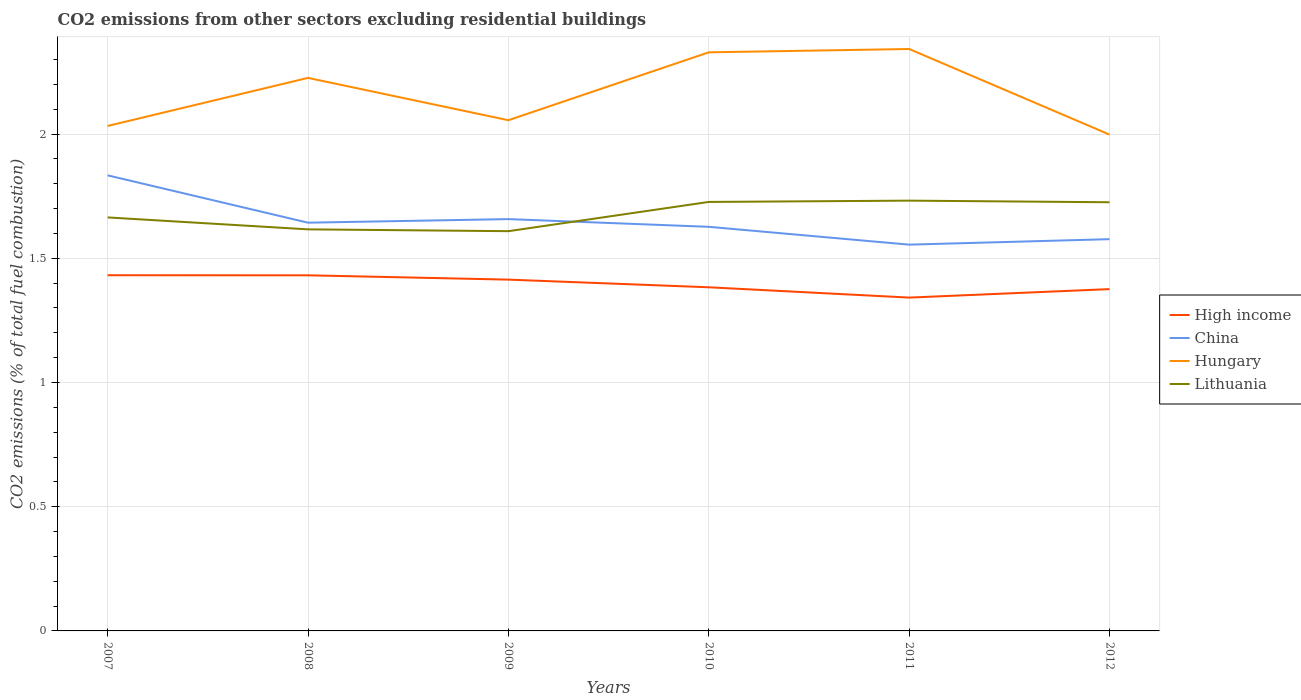How many different coloured lines are there?
Your response must be concise. 4. Across all years, what is the maximum total CO2 emitted in High income?
Provide a short and direct response. 1.34. What is the total total CO2 emitted in Hungary in the graph?
Your answer should be very brief. -0.29. What is the difference between the highest and the second highest total CO2 emitted in High income?
Offer a terse response. 0.09. How many lines are there?
Ensure brevity in your answer.  4. Does the graph contain grids?
Provide a short and direct response. Yes. How are the legend labels stacked?
Offer a terse response. Vertical. What is the title of the graph?
Give a very brief answer. CO2 emissions from other sectors excluding residential buildings. Does "Lesotho" appear as one of the legend labels in the graph?
Your answer should be compact. No. What is the label or title of the X-axis?
Your answer should be compact. Years. What is the label or title of the Y-axis?
Your response must be concise. CO2 emissions (% of total fuel combustion). What is the CO2 emissions (% of total fuel combustion) in High income in 2007?
Your response must be concise. 1.43. What is the CO2 emissions (% of total fuel combustion) of China in 2007?
Offer a very short reply. 1.83. What is the CO2 emissions (% of total fuel combustion) of Hungary in 2007?
Offer a terse response. 2.03. What is the CO2 emissions (% of total fuel combustion) in Lithuania in 2007?
Provide a short and direct response. 1.66. What is the CO2 emissions (% of total fuel combustion) in High income in 2008?
Your response must be concise. 1.43. What is the CO2 emissions (% of total fuel combustion) in China in 2008?
Provide a succinct answer. 1.64. What is the CO2 emissions (% of total fuel combustion) in Hungary in 2008?
Offer a terse response. 2.23. What is the CO2 emissions (% of total fuel combustion) of Lithuania in 2008?
Keep it short and to the point. 1.62. What is the CO2 emissions (% of total fuel combustion) in High income in 2009?
Ensure brevity in your answer.  1.41. What is the CO2 emissions (% of total fuel combustion) in China in 2009?
Your response must be concise. 1.66. What is the CO2 emissions (% of total fuel combustion) in Hungary in 2009?
Offer a very short reply. 2.06. What is the CO2 emissions (% of total fuel combustion) in Lithuania in 2009?
Make the answer very short. 1.61. What is the CO2 emissions (% of total fuel combustion) in High income in 2010?
Make the answer very short. 1.38. What is the CO2 emissions (% of total fuel combustion) in China in 2010?
Provide a short and direct response. 1.63. What is the CO2 emissions (% of total fuel combustion) in Hungary in 2010?
Provide a succinct answer. 2.33. What is the CO2 emissions (% of total fuel combustion) in Lithuania in 2010?
Give a very brief answer. 1.73. What is the CO2 emissions (% of total fuel combustion) in High income in 2011?
Your response must be concise. 1.34. What is the CO2 emissions (% of total fuel combustion) in China in 2011?
Provide a succinct answer. 1.55. What is the CO2 emissions (% of total fuel combustion) in Hungary in 2011?
Ensure brevity in your answer.  2.34. What is the CO2 emissions (% of total fuel combustion) in Lithuania in 2011?
Offer a very short reply. 1.73. What is the CO2 emissions (% of total fuel combustion) in High income in 2012?
Provide a short and direct response. 1.38. What is the CO2 emissions (% of total fuel combustion) of China in 2012?
Make the answer very short. 1.58. What is the CO2 emissions (% of total fuel combustion) in Hungary in 2012?
Keep it short and to the point. 2. What is the CO2 emissions (% of total fuel combustion) of Lithuania in 2012?
Your response must be concise. 1.73. Across all years, what is the maximum CO2 emissions (% of total fuel combustion) of High income?
Ensure brevity in your answer.  1.43. Across all years, what is the maximum CO2 emissions (% of total fuel combustion) in China?
Keep it short and to the point. 1.83. Across all years, what is the maximum CO2 emissions (% of total fuel combustion) in Hungary?
Provide a succinct answer. 2.34. Across all years, what is the maximum CO2 emissions (% of total fuel combustion) in Lithuania?
Keep it short and to the point. 1.73. Across all years, what is the minimum CO2 emissions (% of total fuel combustion) in High income?
Offer a very short reply. 1.34. Across all years, what is the minimum CO2 emissions (% of total fuel combustion) in China?
Offer a terse response. 1.55. Across all years, what is the minimum CO2 emissions (% of total fuel combustion) in Hungary?
Your answer should be compact. 2. Across all years, what is the minimum CO2 emissions (% of total fuel combustion) in Lithuania?
Provide a short and direct response. 1.61. What is the total CO2 emissions (% of total fuel combustion) of High income in the graph?
Your answer should be compact. 8.38. What is the total CO2 emissions (% of total fuel combustion) of China in the graph?
Provide a succinct answer. 9.89. What is the total CO2 emissions (% of total fuel combustion) of Hungary in the graph?
Your response must be concise. 12.98. What is the total CO2 emissions (% of total fuel combustion) in Lithuania in the graph?
Give a very brief answer. 10.07. What is the difference between the CO2 emissions (% of total fuel combustion) of China in 2007 and that in 2008?
Offer a very short reply. 0.19. What is the difference between the CO2 emissions (% of total fuel combustion) in Hungary in 2007 and that in 2008?
Keep it short and to the point. -0.19. What is the difference between the CO2 emissions (% of total fuel combustion) in Lithuania in 2007 and that in 2008?
Your answer should be compact. 0.05. What is the difference between the CO2 emissions (% of total fuel combustion) of High income in 2007 and that in 2009?
Provide a succinct answer. 0.02. What is the difference between the CO2 emissions (% of total fuel combustion) in China in 2007 and that in 2009?
Keep it short and to the point. 0.18. What is the difference between the CO2 emissions (% of total fuel combustion) in Hungary in 2007 and that in 2009?
Your response must be concise. -0.02. What is the difference between the CO2 emissions (% of total fuel combustion) of Lithuania in 2007 and that in 2009?
Your response must be concise. 0.06. What is the difference between the CO2 emissions (% of total fuel combustion) in High income in 2007 and that in 2010?
Your answer should be very brief. 0.05. What is the difference between the CO2 emissions (% of total fuel combustion) of China in 2007 and that in 2010?
Provide a short and direct response. 0.21. What is the difference between the CO2 emissions (% of total fuel combustion) of Hungary in 2007 and that in 2010?
Your response must be concise. -0.3. What is the difference between the CO2 emissions (% of total fuel combustion) of Lithuania in 2007 and that in 2010?
Provide a short and direct response. -0.06. What is the difference between the CO2 emissions (% of total fuel combustion) in High income in 2007 and that in 2011?
Give a very brief answer. 0.09. What is the difference between the CO2 emissions (% of total fuel combustion) in China in 2007 and that in 2011?
Offer a very short reply. 0.28. What is the difference between the CO2 emissions (% of total fuel combustion) of Hungary in 2007 and that in 2011?
Offer a terse response. -0.31. What is the difference between the CO2 emissions (% of total fuel combustion) of Lithuania in 2007 and that in 2011?
Ensure brevity in your answer.  -0.07. What is the difference between the CO2 emissions (% of total fuel combustion) in High income in 2007 and that in 2012?
Offer a very short reply. 0.06. What is the difference between the CO2 emissions (% of total fuel combustion) in China in 2007 and that in 2012?
Offer a very short reply. 0.26. What is the difference between the CO2 emissions (% of total fuel combustion) of Hungary in 2007 and that in 2012?
Your answer should be very brief. 0.03. What is the difference between the CO2 emissions (% of total fuel combustion) of Lithuania in 2007 and that in 2012?
Your answer should be very brief. -0.06. What is the difference between the CO2 emissions (% of total fuel combustion) of High income in 2008 and that in 2009?
Provide a succinct answer. 0.02. What is the difference between the CO2 emissions (% of total fuel combustion) in China in 2008 and that in 2009?
Your response must be concise. -0.01. What is the difference between the CO2 emissions (% of total fuel combustion) of Hungary in 2008 and that in 2009?
Provide a succinct answer. 0.17. What is the difference between the CO2 emissions (% of total fuel combustion) of Lithuania in 2008 and that in 2009?
Your response must be concise. 0.01. What is the difference between the CO2 emissions (% of total fuel combustion) in High income in 2008 and that in 2010?
Make the answer very short. 0.05. What is the difference between the CO2 emissions (% of total fuel combustion) in China in 2008 and that in 2010?
Your answer should be very brief. 0.02. What is the difference between the CO2 emissions (% of total fuel combustion) of Hungary in 2008 and that in 2010?
Make the answer very short. -0.1. What is the difference between the CO2 emissions (% of total fuel combustion) of Lithuania in 2008 and that in 2010?
Your answer should be very brief. -0.11. What is the difference between the CO2 emissions (% of total fuel combustion) of High income in 2008 and that in 2011?
Give a very brief answer. 0.09. What is the difference between the CO2 emissions (% of total fuel combustion) in China in 2008 and that in 2011?
Ensure brevity in your answer.  0.09. What is the difference between the CO2 emissions (% of total fuel combustion) in Hungary in 2008 and that in 2011?
Offer a terse response. -0.12. What is the difference between the CO2 emissions (% of total fuel combustion) in Lithuania in 2008 and that in 2011?
Your answer should be very brief. -0.12. What is the difference between the CO2 emissions (% of total fuel combustion) in High income in 2008 and that in 2012?
Your answer should be compact. 0.06. What is the difference between the CO2 emissions (% of total fuel combustion) of China in 2008 and that in 2012?
Ensure brevity in your answer.  0.07. What is the difference between the CO2 emissions (% of total fuel combustion) of Hungary in 2008 and that in 2012?
Give a very brief answer. 0.23. What is the difference between the CO2 emissions (% of total fuel combustion) in Lithuania in 2008 and that in 2012?
Provide a short and direct response. -0.11. What is the difference between the CO2 emissions (% of total fuel combustion) of High income in 2009 and that in 2010?
Your answer should be very brief. 0.03. What is the difference between the CO2 emissions (% of total fuel combustion) in China in 2009 and that in 2010?
Your answer should be very brief. 0.03. What is the difference between the CO2 emissions (% of total fuel combustion) of Hungary in 2009 and that in 2010?
Your response must be concise. -0.27. What is the difference between the CO2 emissions (% of total fuel combustion) in Lithuania in 2009 and that in 2010?
Your answer should be compact. -0.12. What is the difference between the CO2 emissions (% of total fuel combustion) in High income in 2009 and that in 2011?
Provide a short and direct response. 0.07. What is the difference between the CO2 emissions (% of total fuel combustion) in China in 2009 and that in 2011?
Your answer should be compact. 0.1. What is the difference between the CO2 emissions (% of total fuel combustion) in Hungary in 2009 and that in 2011?
Make the answer very short. -0.29. What is the difference between the CO2 emissions (% of total fuel combustion) in Lithuania in 2009 and that in 2011?
Make the answer very short. -0.12. What is the difference between the CO2 emissions (% of total fuel combustion) of High income in 2009 and that in 2012?
Your answer should be very brief. 0.04. What is the difference between the CO2 emissions (% of total fuel combustion) in China in 2009 and that in 2012?
Your answer should be compact. 0.08. What is the difference between the CO2 emissions (% of total fuel combustion) in Hungary in 2009 and that in 2012?
Provide a short and direct response. 0.06. What is the difference between the CO2 emissions (% of total fuel combustion) in Lithuania in 2009 and that in 2012?
Offer a terse response. -0.12. What is the difference between the CO2 emissions (% of total fuel combustion) in High income in 2010 and that in 2011?
Offer a very short reply. 0.04. What is the difference between the CO2 emissions (% of total fuel combustion) in China in 2010 and that in 2011?
Ensure brevity in your answer.  0.07. What is the difference between the CO2 emissions (% of total fuel combustion) of Hungary in 2010 and that in 2011?
Give a very brief answer. -0.01. What is the difference between the CO2 emissions (% of total fuel combustion) in Lithuania in 2010 and that in 2011?
Ensure brevity in your answer.  -0.01. What is the difference between the CO2 emissions (% of total fuel combustion) in High income in 2010 and that in 2012?
Your answer should be compact. 0.01. What is the difference between the CO2 emissions (% of total fuel combustion) of China in 2010 and that in 2012?
Your answer should be very brief. 0.05. What is the difference between the CO2 emissions (% of total fuel combustion) of Hungary in 2010 and that in 2012?
Your response must be concise. 0.33. What is the difference between the CO2 emissions (% of total fuel combustion) in Lithuania in 2010 and that in 2012?
Ensure brevity in your answer.  0. What is the difference between the CO2 emissions (% of total fuel combustion) of High income in 2011 and that in 2012?
Ensure brevity in your answer.  -0.03. What is the difference between the CO2 emissions (% of total fuel combustion) in China in 2011 and that in 2012?
Keep it short and to the point. -0.02. What is the difference between the CO2 emissions (% of total fuel combustion) of Hungary in 2011 and that in 2012?
Keep it short and to the point. 0.34. What is the difference between the CO2 emissions (% of total fuel combustion) of Lithuania in 2011 and that in 2012?
Make the answer very short. 0.01. What is the difference between the CO2 emissions (% of total fuel combustion) of High income in 2007 and the CO2 emissions (% of total fuel combustion) of China in 2008?
Your answer should be very brief. -0.21. What is the difference between the CO2 emissions (% of total fuel combustion) of High income in 2007 and the CO2 emissions (% of total fuel combustion) of Hungary in 2008?
Keep it short and to the point. -0.79. What is the difference between the CO2 emissions (% of total fuel combustion) of High income in 2007 and the CO2 emissions (% of total fuel combustion) of Lithuania in 2008?
Provide a short and direct response. -0.18. What is the difference between the CO2 emissions (% of total fuel combustion) in China in 2007 and the CO2 emissions (% of total fuel combustion) in Hungary in 2008?
Your response must be concise. -0.39. What is the difference between the CO2 emissions (% of total fuel combustion) in China in 2007 and the CO2 emissions (% of total fuel combustion) in Lithuania in 2008?
Your answer should be compact. 0.22. What is the difference between the CO2 emissions (% of total fuel combustion) of Hungary in 2007 and the CO2 emissions (% of total fuel combustion) of Lithuania in 2008?
Your answer should be compact. 0.42. What is the difference between the CO2 emissions (% of total fuel combustion) of High income in 2007 and the CO2 emissions (% of total fuel combustion) of China in 2009?
Your response must be concise. -0.23. What is the difference between the CO2 emissions (% of total fuel combustion) in High income in 2007 and the CO2 emissions (% of total fuel combustion) in Hungary in 2009?
Your answer should be very brief. -0.62. What is the difference between the CO2 emissions (% of total fuel combustion) in High income in 2007 and the CO2 emissions (% of total fuel combustion) in Lithuania in 2009?
Keep it short and to the point. -0.18. What is the difference between the CO2 emissions (% of total fuel combustion) of China in 2007 and the CO2 emissions (% of total fuel combustion) of Hungary in 2009?
Make the answer very short. -0.22. What is the difference between the CO2 emissions (% of total fuel combustion) in China in 2007 and the CO2 emissions (% of total fuel combustion) in Lithuania in 2009?
Offer a terse response. 0.22. What is the difference between the CO2 emissions (% of total fuel combustion) of Hungary in 2007 and the CO2 emissions (% of total fuel combustion) of Lithuania in 2009?
Offer a terse response. 0.42. What is the difference between the CO2 emissions (% of total fuel combustion) in High income in 2007 and the CO2 emissions (% of total fuel combustion) in China in 2010?
Give a very brief answer. -0.19. What is the difference between the CO2 emissions (% of total fuel combustion) in High income in 2007 and the CO2 emissions (% of total fuel combustion) in Hungary in 2010?
Make the answer very short. -0.9. What is the difference between the CO2 emissions (% of total fuel combustion) of High income in 2007 and the CO2 emissions (% of total fuel combustion) of Lithuania in 2010?
Your response must be concise. -0.3. What is the difference between the CO2 emissions (% of total fuel combustion) in China in 2007 and the CO2 emissions (% of total fuel combustion) in Hungary in 2010?
Ensure brevity in your answer.  -0.5. What is the difference between the CO2 emissions (% of total fuel combustion) in China in 2007 and the CO2 emissions (% of total fuel combustion) in Lithuania in 2010?
Provide a succinct answer. 0.11. What is the difference between the CO2 emissions (% of total fuel combustion) of Hungary in 2007 and the CO2 emissions (% of total fuel combustion) of Lithuania in 2010?
Provide a short and direct response. 0.31. What is the difference between the CO2 emissions (% of total fuel combustion) in High income in 2007 and the CO2 emissions (% of total fuel combustion) in China in 2011?
Your answer should be very brief. -0.12. What is the difference between the CO2 emissions (% of total fuel combustion) in High income in 2007 and the CO2 emissions (% of total fuel combustion) in Hungary in 2011?
Offer a terse response. -0.91. What is the difference between the CO2 emissions (% of total fuel combustion) in High income in 2007 and the CO2 emissions (% of total fuel combustion) in Lithuania in 2011?
Provide a succinct answer. -0.3. What is the difference between the CO2 emissions (% of total fuel combustion) of China in 2007 and the CO2 emissions (% of total fuel combustion) of Hungary in 2011?
Provide a short and direct response. -0.51. What is the difference between the CO2 emissions (% of total fuel combustion) of China in 2007 and the CO2 emissions (% of total fuel combustion) of Lithuania in 2011?
Your answer should be very brief. 0.1. What is the difference between the CO2 emissions (% of total fuel combustion) of Hungary in 2007 and the CO2 emissions (% of total fuel combustion) of Lithuania in 2011?
Offer a very short reply. 0.3. What is the difference between the CO2 emissions (% of total fuel combustion) of High income in 2007 and the CO2 emissions (% of total fuel combustion) of China in 2012?
Give a very brief answer. -0.15. What is the difference between the CO2 emissions (% of total fuel combustion) in High income in 2007 and the CO2 emissions (% of total fuel combustion) in Hungary in 2012?
Provide a short and direct response. -0.57. What is the difference between the CO2 emissions (% of total fuel combustion) of High income in 2007 and the CO2 emissions (% of total fuel combustion) of Lithuania in 2012?
Keep it short and to the point. -0.29. What is the difference between the CO2 emissions (% of total fuel combustion) in China in 2007 and the CO2 emissions (% of total fuel combustion) in Hungary in 2012?
Ensure brevity in your answer.  -0.16. What is the difference between the CO2 emissions (% of total fuel combustion) of China in 2007 and the CO2 emissions (% of total fuel combustion) of Lithuania in 2012?
Keep it short and to the point. 0.11. What is the difference between the CO2 emissions (% of total fuel combustion) of Hungary in 2007 and the CO2 emissions (% of total fuel combustion) of Lithuania in 2012?
Keep it short and to the point. 0.31. What is the difference between the CO2 emissions (% of total fuel combustion) in High income in 2008 and the CO2 emissions (% of total fuel combustion) in China in 2009?
Offer a terse response. -0.23. What is the difference between the CO2 emissions (% of total fuel combustion) in High income in 2008 and the CO2 emissions (% of total fuel combustion) in Hungary in 2009?
Your answer should be compact. -0.62. What is the difference between the CO2 emissions (% of total fuel combustion) in High income in 2008 and the CO2 emissions (% of total fuel combustion) in Lithuania in 2009?
Provide a succinct answer. -0.18. What is the difference between the CO2 emissions (% of total fuel combustion) of China in 2008 and the CO2 emissions (% of total fuel combustion) of Hungary in 2009?
Provide a short and direct response. -0.41. What is the difference between the CO2 emissions (% of total fuel combustion) in China in 2008 and the CO2 emissions (% of total fuel combustion) in Lithuania in 2009?
Your answer should be very brief. 0.03. What is the difference between the CO2 emissions (% of total fuel combustion) of Hungary in 2008 and the CO2 emissions (% of total fuel combustion) of Lithuania in 2009?
Ensure brevity in your answer.  0.62. What is the difference between the CO2 emissions (% of total fuel combustion) in High income in 2008 and the CO2 emissions (% of total fuel combustion) in China in 2010?
Your answer should be compact. -0.2. What is the difference between the CO2 emissions (% of total fuel combustion) in High income in 2008 and the CO2 emissions (% of total fuel combustion) in Hungary in 2010?
Make the answer very short. -0.9. What is the difference between the CO2 emissions (% of total fuel combustion) of High income in 2008 and the CO2 emissions (% of total fuel combustion) of Lithuania in 2010?
Give a very brief answer. -0.3. What is the difference between the CO2 emissions (% of total fuel combustion) of China in 2008 and the CO2 emissions (% of total fuel combustion) of Hungary in 2010?
Your answer should be very brief. -0.69. What is the difference between the CO2 emissions (% of total fuel combustion) of China in 2008 and the CO2 emissions (% of total fuel combustion) of Lithuania in 2010?
Your answer should be compact. -0.08. What is the difference between the CO2 emissions (% of total fuel combustion) in Hungary in 2008 and the CO2 emissions (% of total fuel combustion) in Lithuania in 2010?
Make the answer very short. 0.5. What is the difference between the CO2 emissions (% of total fuel combustion) of High income in 2008 and the CO2 emissions (% of total fuel combustion) of China in 2011?
Ensure brevity in your answer.  -0.12. What is the difference between the CO2 emissions (% of total fuel combustion) of High income in 2008 and the CO2 emissions (% of total fuel combustion) of Hungary in 2011?
Make the answer very short. -0.91. What is the difference between the CO2 emissions (% of total fuel combustion) in High income in 2008 and the CO2 emissions (% of total fuel combustion) in Lithuania in 2011?
Give a very brief answer. -0.3. What is the difference between the CO2 emissions (% of total fuel combustion) of China in 2008 and the CO2 emissions (% of total fuel combustion) of Hungary in 2011?
Your response must be concise. -0.7. What is the difference between the CO2 emissions (% of total fuel combustion) in China in 2008 and the CO2 emissions (% of total fuel combustion) in Lithuania in 2011?
Keep it short and to the point. -0.09. What is the difference between the CO2 emissions (% of total fuel combustion) in Hungary in 2008 and the CO2 emissions (% of total fuel combustion) in Lithuania in 2011?
Keep it short and to the point. 0.49. What is the difference between the CO2 emissions (% of total fuel combustion) of High income in 2008 and the CO2 emissions (% of total fuel combustion) of China in 2012?
Make the answer very short. -0.15. What is the difference between the CO2 emissions (% of total fuel combustion) of High income in 2008 and the CO2 emissions (% of total fuel combustion) of Hungary in 2012?
Offer a terse response. -0.57. What is the difference between the CO2 emissions (% of total fuel combustion) in High income in 2008 and the CO2 emissions (% of total fuel combustion) in Lithuania in 2012?
Provide a succinct answer. -0.29. What is the difference between the CO2 emissions (% of total fuel combustion) of China in 2008 and the CO2 emissions (% of total fuel combustion) of Hungary in 2012?
Your answer should be very brief. -0.35. What is the difference between the CO2 emissions (% of total fuel combustion) in China in 2008 and the CO2 emissions (% of total fuel combustion) in Lithuania in 2012?
Give a very brief answer. -0.08. What is the difference between the CO2 emissions (% of total fuel combustion) in Hungary in 2008 and the CO2 emissions (% of total fuel combustion) in Lithuania in 2012?
Your answer should be compact. 0.5. What is the difference between the CO2 emissions (% of total fuel combustion) of High income in 2009 and the CO2 emissions (% of total fuel combustion) of China in 2010?
Offer a very short reply. -0.21. What is the difference between the CO2 emissions (% of total fuel combustion) of High income in 2009 and the CO2 emissions (% of total fuel combustion) of Hungary in 2010?
Ensure brevity in your answer.  -0.91. What is the difference between the CO2 emissions (% of total fuel combustion) of High income in 2009 and the CO2 emissions (% of total fuel combustion) of Lithuania in 2010?
Keep it short and to the point. -0.31. What is the difference between the CO2 emissions (% of total fuel combustion) in China in 2009 and the CO2 emissions (% of total fuel combustion) in Hungary in 2010?
Give a very brief answer. -0.67. What is the difference between the CO2 emissions (% of total fuel combustion) in China in 2009 and the CO2 emissions (% of total fuel combustion) in Lithuania in 2010?
Keep it short and to the point. -0.07. What is the difference between the CO2 emissions (% of total fuel combustion) in Hungary in 2009 and the CO2 emissions (% of total fuel combustion) in Lithuania in 2010?
Your answer should be very brief. 0.33. What is the difference between the CO2 emissions (% of total fuel combustion) of High income in 2009 and the CO2 emissions (% of total fuel combustion) of China in 2011?
Provide a short and direct response. -0.14. What is the difference between the CO2 emissions (% of total fuel combustion) in High income in 2009 and the CO2 emissions (% of total fuel combustion) in Hungary in 2011?
Your answer should be compact. -0.93. What is the difference between the CO2 emissions (% of total fuel combustion) of High income in 2009 and the CO2 emissions (% of total fuel combustion) of Lithuania in 2011?
Your answer should be compact. -0.32. What is the difference between the CO2 emissions (% of total fuel combustion) of China in 2009 and the CO2 emissions (% of total fuel combustion) of Hungary in 2011?
Offer a very short reply. -0.68. What is the difference between the CO2 emissions (% of total fuel combustion) in China in 2009 and the CO2 emissions (% of total fuel combustion) in Lithuania in 2011?
Give a very brief answer. -0.07. What is the difference between the CO2 emissions (% of total fuel combustion) of Hungary in 2009 and the CO2 emissions (% of total fuel combustion) of Lithuania in 2011?
Give a very brief answer. 0.32. What is the difference between the CO2 emissions (% of total fuel combustion) in High income in 2009 and the CO2 emissions (% of total fuel combustion) in China in 2012?
Keep it short and to the point. -0.16. What is the difference between the CO2 emissions (% of total fuel combustion) of High income in 2009 and the CO2 emissions (% of total fuel combustion) of Hungary in 2012?
Your response must be concise. -0.58. What is the difference between the CO2 emissions (% of total fuel combustion) in High income in 2009 and the CO2 emissions (% of total fuel combustion) in Lithuania in 2012?
Offer a very short reply. -0.31. What is the difference between the CO2 emissions (% of total fuel combustion) in China in 2009 and the CO2 emissions (% of total fuel combustion) in Hungary in 2012?
Make the answer very short. -0.34. What is the difference between the CO2 emissions (% of total fuel combustion) of China in 2009 and the CO2 emissions (% of total fuel combustion) of Lithuania in 2012?
Provide a short and direct response. -0.07. What is the difference between the CO2 emissions (% of total fuel combustion) of Hungary in 2009 and the CO2 emissions (% of total fuel combustion) of Lithuania in 2012?
Ensure brevity in your answer.  0.33. What is the difference between the CO2 emissions (% of total fuel combustion) of High income in 2010 and the CO2 emissions (% of total fuel combustion) of China in 2011?
Offer a terse response. -0.17. What is the difference between the CO2 emissions (% of total fuel combustion) of High income in 2010 and the CO2 emissions (% of total fuel combustion) of Hungary in 2011?
Offer a terse response. -0.96. What is the difference between the CO2 emissions (% of total fuel combustion) of High income in 2010 and the CO2 emissions (% of total fuel combustion) of Lithuania in 2011?
Keep it short and to the point. -0.35. What is the difference between the CO2 emissions (% of total fuel combustion) in China in 2010 and the CO2 emissions (% of total fuel combustion) in Hungary in 2011?
Ensure brevity in your answer.  -0.72. What is the difference between the CO2 emissions (% of total fuel combustion) of China in 2010 and the CO2 emissions (% of total fuel combustion) of Lithuania in 2011?
Offer a terse response. -0.11. What is the difference between the CO2 emissions (% of total fuel combustion) of Hungary in 2010 and the CO2 emissions (% of total fuel combustion) of Lithuania in 2011?
Your response must be concise. 0.6. What is the difference between the CO2 emissions (% of total fuel combustion) in High income in 2010 and the CO2 emissions (% of total fuel combustion) in China in 2012?
Your response must be concise. -0.19. What is the difference between the CO2 emissions (% of total fuel combustion) of High income in 2010 and the CO2 emissions (% of total fuel combustion) of Hungary in 2012?
Your answer should be compact. -0.61. What is the difference between the CO2 emissions (% of total fuel combustion) in High income in 2010 and the CO2 emissions (% of total fuel combustion) in Lithuania in 2012?
Ensure brevity in your answer.  -0.34. What is the difference between the CO2 emissions (% of total fuel combustion) of China in 2010 and the CO2 emissions (% of total fuel combustion) of Hungary in 2012?
Your answer should be compact. -0.37. What is the difference between the CO2 emissions (% of total fuel combustion) of China in 2010 and the CO2 emissions (% of total fuel combustion) of Lithuania in 2012?
Keep it short and to the point. -0.1. What is the difference between the CO2 emissions (% of total fuel combustion) in Hungary in 2010 and the CO2 emissions (% of total fuel combustion) in Lithuania in 2012?
Your response must be concise. 0.6. What is the difference between the CO2 emissions (% of total fuel combustion) of High income in 2011 and the CO2 emissions (% of total fuel combustion) of China in 2012?
Provide a short and direct response. -0.24. What is the difference between the CO2 emissions (% of total fuel combustion) of High income in 2011 and the CO2 emissions (% of total fuel combustion) of Hungary in 2012?
Offer a terse response. -0.66. What is the difference between the CO2 emissions (% of total fuel combustion) of High income in 2011 and the CO2 emissions (% of total fuel combustion) of Lithuania in 2012?
Keep it short and to the point. -0.38. What is the difference between the CO2 emissions (% of total fuel combustion) of China in 2011 and the CO2 emissions (% of total fuel combustion) of Hungary in 2012?
Offer a terse response. -0.44. What is the difference between the CO2 emissions (% of total fuel combustion) of China in 2011 and the CO2 emissions (% of total fuel combustion) of Lithuania in 2012?
Give a very brief answer. -0.17. What is the difference between the CO2 emissions (% of total fuel combustion) of Hungary in 2011 and the CO2 emissions (% of total fuel combustion) of Lithuania in 2012?
Your response must be concise. 0.62. What is the average CO2 emissions (% of total fuel combustion) of High income per year?
Your response must be concise. 1.4. What is the average CO2 emissions (% of total fuel combustion) of China per year?
Your answer should be compact. 1.65. What is the average CO2 emissions (% of total fuel combustion) in Hungary per year?
Offer a very short reply. 2.16. What is the average CO2 emissions (% of total fuel combustion) of Lithuania per year?
Provide a succinct answer. 1.68. In the year 2007, what is the difference between the CO2 emissions (% of total fuel combustion) of High income and CO2 emissions (% of total fuel combustion) of China?
Your response must be concise. -0.4. In the year 2007, what is the difference between the CO2 emissions (% of total fuel combustion) in High income and CO2 emissions (% of total fuel combustion) in Hungary?
Give a very brief answer. -0.6. In the year 2007, what is the difference between the CO2 emissions (% of total fuel combustion) of High income and CO2 emissions (% of total fuel combustion) of Lithuania?
Offer a terse response. -0.23. In the year 2007, what is the difference between the CO2 emissions (% of total fuel combustion) in China and CO2 emissions (% of total fuel combustion) in Hungary?
Ensure brevity in your answer.  -0.2. In the year 2007, what is the difference between the CO2 emissions (% of total fuel combustion) of China and CO2 emissions (% of total fuel combustion) of Lithuania?
Your response must be concise. 0.17. In the year 2007, what is the difference between the CO2 emissions (% of total fuel combustion) of Hungary and CO2 emissions (% of total fuel combustion) of Lithuania?
Offer a very short reply. 0.37. In the year 2008, what is the difference between the CO2 emissions (% of total fuel combustion) in High income and CO2 emissions (% of total fuel combustion) in China?
Offer a very short reply. -0.21. In the year 2008, what is the difference between the CO2 emissions (% of total fuel combustion) in High income and CO2 emissions (% of total fuel combustion) in Hungary?
Ensure brevity in your answer.  -0.79. In the year 2008, what is the difference between the CO2 emissions (% of total fuel combustion) of High income and CO2 emissions (% of total fuel combustion) of Lithuania?
Make the answer very short. -0.18. In the year 2008, what is the difference between the CO2 emissions (% of total fuel combustion) in China and CO2 emissions (% of total fuel combustion) in Hungary?
Give a very brief answer. -0.58. In the year 2008, what is the difference between the CO2 emissions (% of total fuel combustion) in China and CO2 emissions (% of total fuel combustion) in Lithuania?
Provide a short and direct response. 0.03. In the year 2008, what is the difference between the CO2 emissions (% of total fuel combustion) of Hungary and CO2 emissions (% of total fuel combustion) of Lithuania?
Ensure brevity in your answer.  0.61. In the year 2009, what is the difference between the CO2 emissions (% of total fuel combustion) in High income and CO2 emissions (% of total fuel combustion) in China?
Provide a succinct answer. -0.24. In the year 2009, what is the difference between the CO2 emissions (% of total fuel combustion) of High income and CO2 emissions (% of total fuel combustion) of Hungary?
Ensure brevity in your answer.  -0.64. In the year 2009, what is the difference between the CO2 emissions (% of total fuel combustion) of High income and CO2 emissions (% of total fuel combustion) of Lithuania?
Your answer should be very brief. -0.2. In the year 2009, what is the difference between the CO2 emissions (% of total fuel combustion) in China and CO2 emissions (% of total fuel combustion) in Hungary?
Provide a short and direct response. -0.4. In the year 2009, what is the difference between the CO2 emissions (% of total fuel combustion) of China and CO2 emissions (% of total fuel combustion) of Lithuania?
Keep it short and to the point. 0.05. In the year 2009, what is the difference between the CO2 emissions (% of total fuel combustion) in Hungary and CO2 emissions (% of total fuel combustion) in Lithuania?
Offer a terse response. 0.45. In the year 2010, what is the difference between the CO2 emissions (% of total fuel combustion) of High income and CO2 emissions (% of total fuel combustion) of China?
Keep it short and to the point. -0.24. In the year 2010, what is the difference between the CO2 emissions (% of total fuel combustion) of High income and CO2 emissions (% of total fuel combustion) of Hungary?
Provide a succinct answer. -0.95. In the year 2010, what is the difference between the CO2 emissions (% of total fuel combustion) of High income and CO2 emissions (% of total fuel combustion) of Lithuania?
Give a very brief answer. -0.34. In the year 2010, what is the difference between the CO2 emissions (% of total fuel combustion) in China and CO2 emissions (% of total fuel combustion) in Hungary?
Make the answer very short. -0.7. In the year 2010, what is the difference between the CO2 emissions (% of total fuel combustion) in China and CO2 emissions (% of total fuel combustion) in Lithuania?
Your answer should be very brief. -0.1. In the year 2010, what is the difference between the CO2 emissions (% of total fuel combustion) in Hungary and CO2 emissions (% of total fuel combustion) in Lithuania?
Give a very brief answer. 0.6. In the year 2011, what is the difference between the CO2 emissions (% of total fuel combustion) of High income and CO2 emissions (% of total fuel combustion) of China?
Your answer should be very brief. -0.21. In the year 2011, what is the difference between the CO2 emissions (% of total fuel combustion) in High income and CO2 emissions (% of total fuel combustion) in Hungary?
Ensure brevity in your answer.  -1. In the year 2011, what is the difference between the CO2 emissions (% of total fuel combustion) in High income and CO2 emissions (% of total fuel combustion) in Lithuania?
Your response must be concise. -0.39. In the year 2011, what is the difference between the CO2 emissions (% of total fuel combustion) of China and CO2 emissions (% of total fuel combustion) of Hungary?
Offer a terse response. -0.79. In the year 2011, what is the difference between the CO2 emissions (% of total fuel combustion) of China and CO2 emissions (% of total fuel combustion) of Lithuania?
Ensure brevity in your answer.  -0.18. In the year 2011, what is the difference between the CO2 emissions (% of total fuel combustion) in Hungary and CO2 emissions (% of total fuel combustion) in Lithuania?
Offer a very short reply. 0.61. In the year 2012, what is the difference between the CO2 emissions (% of total fuel combustion) in High income and CO2 emissions (% of total fuel combustion) in China?
Make the answer very short. -0.2. In the year 2012, what is the difference between the CO2 emissions (% of total fuel combustion) in High income and CO2 emissions (% of total fuel combustion) in Hungary?
Your response must be concise. -0.62. In the year 2012, what is the difference between the CO2 emissions (% of total fuel combustion) in High income and CO2 emissions (% of total fuel combustion) in Lithuania?
Your response must be concise. -0.35. In the year 2012, what is the difference between the CO2 emissions (% of total fuel combustion) of China and CO2 emissions (% of total fuel combustion) of Hungary?
Provide a succinct answer. -0.42. In the year 2012, what is the difference between the CO2 emissions (% of total fuel combustion) of China and CO2 emissions (% of total fuel combustion) of Lithuania?
Offer a very short reply. -0.15. In the year 2012, what is the difference between the CO2 emissions (% of total fuel combustion) in Hungary and CO2 emissions (% of total fuel combustion) in Lithuania?
Provide a short and direct response. 0.27. What is the ratio of the CO2 emissions (% of total fuel combustion) in China in 2007 to that in 2008?
Offer a terse response. 1.12. What is the ratio of the CO2 emissions (% of total fuel combustion) in Hungary in 2007 to that in 2008?
Your response must be concise. 0.91. What is the ratio of the CO2 emissions (% of total fuel combustion) of Lithuania in 2007 to that in 2008?
Keep it short and to the point. 1.03. What is the ratio of the CO2 emissions (% of total fuel combustion) of High income in 2007 to that in 2009?
Your response must be concise. 1.01. What is the ratio of the CO2 emissions (% of total fuel combustion) in China in 2007 to that in 2009?
Provide a short and direct response. 1.11. What is the ratio of the CO2 emissions (% of total fuel combustion) in Hungary in 2007 to that in 2009?
Make the answer very short. 0.99. What is the ratio of the CO2 emissions (% of total fuel combustion) of Lithuania in 2007 to that in 2009?
Your response must be concise. 1.03. What is the ratio of the CO2 emissions (% of total fuel combustion) in High income in 2007 to that in 2010?
Provide a succinct answer. 1.03. What is the ratio of the CO2 emissions (% of total fuel combustion) of China in 2007 to that in 2010?
Keep it short and to the point. 1.13. What is the ratio of the CO2 emissions (% of total fuel combustion) of Hungary in 2007 to that in 2010?
Offer a very short reply. 0.87. What is the ratio of the CO2 emissions (% of total fuel combustion) of Lithuania in 2007 to that in 2010?
Offer a terse response. 0.96. What is the ratio of the CO2 emissions (% of total fuel combustion) of High income in 2007 to that in 2011?
Offer a very short reply. 1.07. What is the ratio of the CO2 emissions (% of total fuel combustion) in China in 2007 to that in 2011?
Make the answer very short. 1.18. What is the ratio of the CO2 emissions (% of total fuel combustion) in Hungary in 2007 to that in 2011?
Provide a short and direct response. 0.87. What is the ratio of the CO2 emissions (% of total fuel combustion) of High income in 2007 to that in 2012?
Give a very brief answer. 1.04. What is the ratio of the CO2 emissions (% of total fuel combustion) in China in 2007 to that in 2012?
Keep it short and to the point. 1.16. What is the ratio of the CO2 emissions (% of total fuel combustion) in Hungary in 2007 to that in 2012?
Ensure brevity in your answer.  1.02. What is the ratio of the CO2 emissions (% of total fuel combustion) of Lithuania in 2007 to that in 2012?
Provide a succinct answer. 0.96. What is the ratio of the CO2 emissions (% of total fuel combustion) in High income in 2008 to that in 2009?
Your response must be concise. 1.01. What is the ratio of the CO2 emissions (% of total fuel combustion) of Hungary in 2008 to that in 2009?
Provide a short and direct response. 1.08. What is the ratio of the CO2 emissions (% of total fuel combustion) in Lithuania in 2008 to that in 2009?
Ensure brevity in your answer.  1. What is the ratio of the CO2 emissions (% of total fuel combustion) in High income in 2008 to that in 2010?
Ensure brevity in your answer.  1.03. What is the ratio of the CO2 emissions (% of total fuel combustion) of China in 2008 to that in 2010?
Make the answer very short. 1.01. What is the ratio of the CO2 emissions (% of total fuel combustion) of Hungary in 2008 to that in 2010?
Offer a very short reply. 0.96. What is the ratio of the CO2 emissions (% of total fuel combustion) in Lithuania in 2008 to that in 2010?
Offer a terse response. 0.94. What is the ratio of the CO2 emissions (% of total fuel combustion) of High income in 2008 to that in 2011?
Give a very brief answer. 1.07. What is the ratio of the CO2 emissions (% of total fuel combustion) of China in 2008 to that in 2011?
Keep it short and to the point. 1.06. What is the ratio of the CO2 emissions (% of total fuel combustion) in Hungary in 2008 to that in 2011?
Your answer should be compact. 0.95. What is the ratio of the CO2 emissions (% of total fuel combustion) in Lithuania in 2008 to that in 2011?
Provide a short and direct response. 0.93. What is the ratio of the CO2 emissions (% of total fuel combustion) of High income in 2008 to that in 2012?
Your answer should be compact. 1.04. What is the ratio of the CO2 emissions (% of total fuel combustion) in China in 2008 to that in 2012?
Provide a short and direct response. 1.04. What is the ratio of the CO2 emissions (% of total fuel combustion) in Hungary in 2008 to that in 2012?
Your answer should be compact. 1.11. What is the ratio of the CO2 emissions (% of total fuel combustion) in Lithuania in 2008 to that in 2012?
Make the answer very short. 0.94. What is the ratio of the CO2 emissions (% of total fuel combustion) of High income in 2009 to that in 2010?
Your answer should be compact. 1.02. What is the ratio of the CO2 emissions (% of total fuel combustion) of China in 2009 to that in 2010?
Give a very brief answer. 1.02. What is the ratio of the CO2 emissions (% of total fuel combustion) of Hungary in 2009 to that in 2010?
Ensure brevity in your answer.  0.88. What is the ratio of the CO2 emissions (% of total fuel combustion) in Lithuania in 2009 to that in 2010?
Ensure brevity in your answer.  0.93. What is the ratio of the CO2 emissions (% of total fuel combustion) of High income in 2009 to that in 2011?
Provide a succinct answer. 1.05. What is the ratio of the CO2 emissions (% of total fuel combustion) in China in 2009 to that in 2011?
Your answer should be compact. 1.07. What is the ratio of the CO2 emissions (% of total fuel combustion) of Hungary in 2009 to that in 2011?
Offer a very short reply. 0.88. What is the ratio of the CO2 emissions (% of total fuel combustion) of Lithuania in 2009 to that in 2011?
Provide a short and direct response. 0.93. What is the ratio of the CO2 emissions (% of total fuel combustion) of High income in 2009 to that in 2012?
Provide a short and direct response. 1.03. What is the ratio of the CO2 emissions (% of total fuel combustion) of China in 2009 to that in 2012?
Your answer should be compact. 1.05. What is the ratio of the CO2 emissions (% of total fuel combustion) in Hungary in 2009 to that in 2012?
Offer a very short reply. 1.03. What is the ratio of the CO2 emissions (% of total fuel combustion) in Lithuania in 2009 to that in 2012?
Offer a terse response. 0.93. What is the ratio of the CO2 emissions (% of total fuel combustion) of High income in 2010 to that in 2011?
Your answer should be very brief. 1.03. What is the ratio of the CO2 emissions (% of total fuel combustion) in China in 2010 to that in 2011?
Your response must be concise. 1.05. What is the ratio of the CO2 emissions (% of total fuel combustion) in High income in 2010 to that in 2012?
Your answer should be very brief. 1.01. What is the ratio of the CO2 emissions (% of total fuel combustion) in China in 2010 to that in 2012?
Make the answer very short. 1.03. What is the ratio of the CO2 emissions (% of total fuel combustion) in Hungary in 2010 to that in 2012?
Provide a succinct answer. 1.17. What is the ratio of the CO2 emissions (% of total fuel combustion) of Lithuania in 2010 to that in 2012?
Provide a succinct answer. 1. What is the ratio of the CO2 emissions (% of total fuel combustion) of High income in 2011 to that in 2012?
Make the answer very short. 0.98. What is the ratio of the CO2 emissions (% of total fuel combustion) of China in 2011 to that in 2012?
Provide a short and direct response. 0.99. What is the ratio of the CO2 emissions (% of total fuel combustion) of Hungary in 2011 to that in 2012?
Your response must be concise. 1.17. What is the ratio of the CO2 emissions (% of total fuel combustion) in Lithuania in 2011 to that in 2012?
Make the answer very short. 1. What is the difference between the highest and the second highest CO2 emissions (% of total fuel combustion) of High income?
Make the answer very short. 0. What is the difference between the highest and the second highest CO2 emissions (% of total fuel combustion) in China?
Provide a succinct answer. 0.18. What is the difference between the highest and the second highest CO2 emissions (% of total fuel combustion) of Hungary?
Offer a very short reply. 0.01. What is the difference between the highest and the second highest CO2 emissions (% of total fuel combustion) in Lithuania?
Offer a terse response. 0.01. What is the difference between the highest and the lowest CO2 emissions (% of total fuel combustion) of High income?
Provide a succinct answer. 0.09. What is the difference between the highest and the lowest CO2 emissions (% of total fuel combustion) in China?
Provide a succinct answer. 0.28. What is the difference between the highest and the lowest CO2 emissions (% of total fuel combustion) of Hungary?
Offer a terse response. 0.34. What is the difference between the highest and the lowest CO2 emissions (% of total fuel combustion) of Lithuania?
Provide a short and direct response. 0.12. 